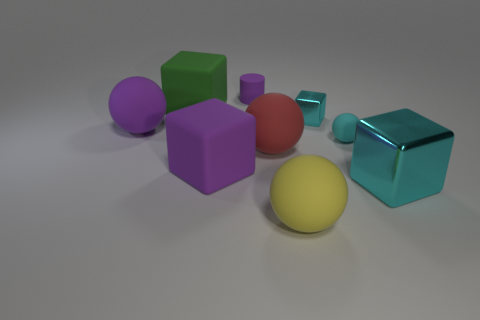What materials are represented by the objects in the image? The objects in the image showcase a variety of materials, including matte textures often associated with plastic or rubber, as well as metallic surfaces that have a shiny, reflective quality. 